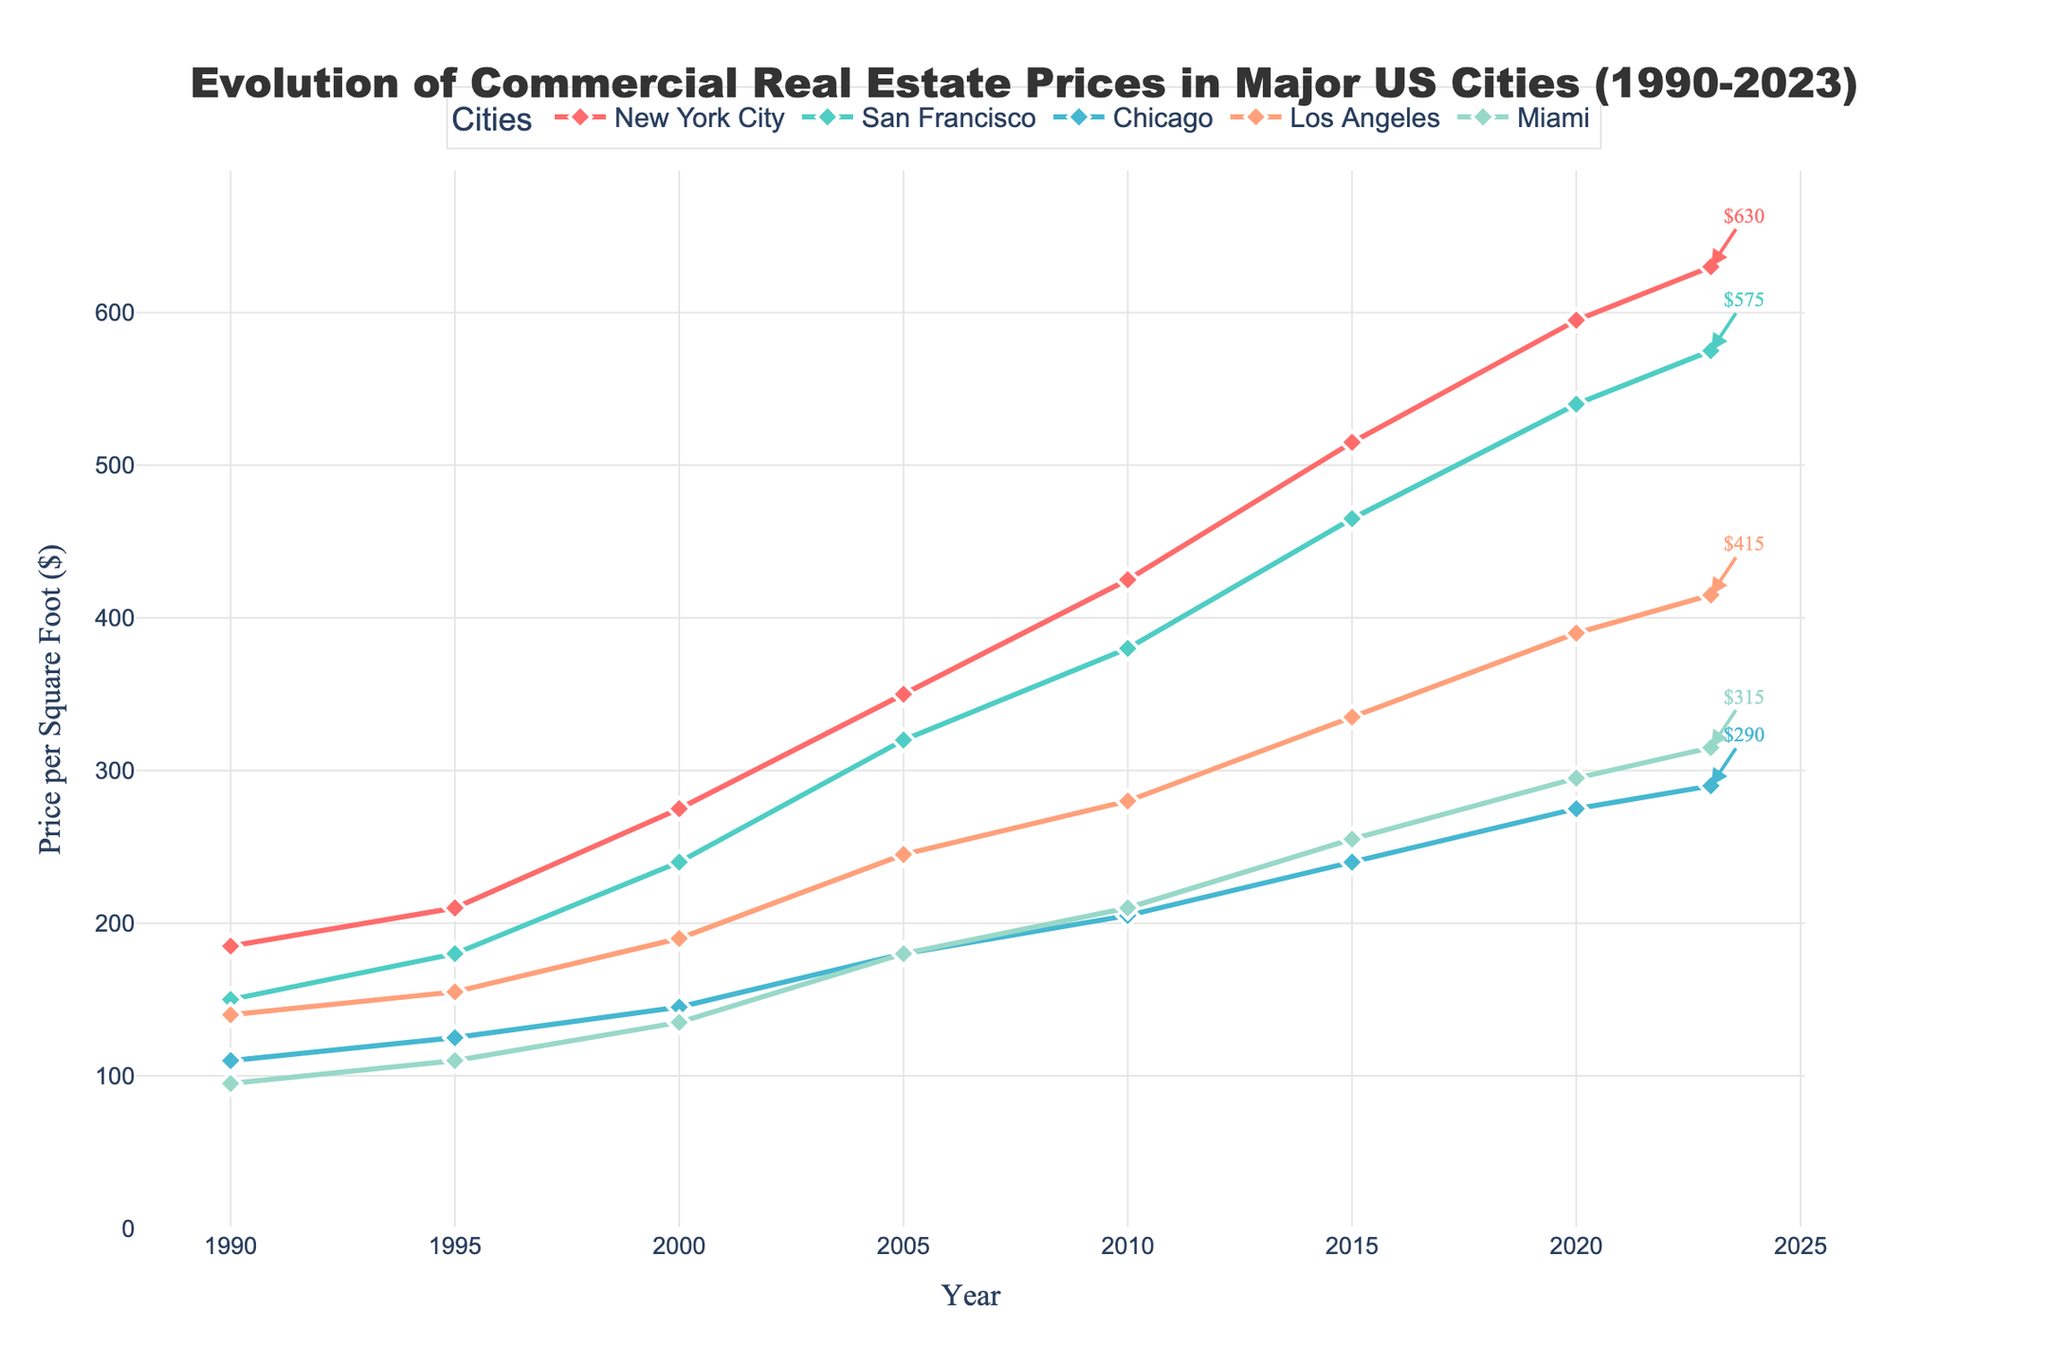What was the commercial real estate price per square foot in New York City in 1990? Identify the point on the plot corresponding to New York City and the year 1990. The value at this point is 185.
Answer: 185 Which city had the highest average commercial real estate price per square foot in 2023? Locate the year 2023 on the x-axis and compare the endpoints of the lines representing each city. The highest point is New York City with $630 per square foot.
Answer: New York City By how much did the commercial real estate price in Miami increase from 1990 to 2023? Find the values for Miami for the years 1990 and 2023, which are 95 and 315 respectively. Calculate the increase as 315 - 95.
Answer: 220 Which two cities had the closest commercial real estate prices per square foot in 2023? Compare the endpoints of the lines for the year 2023 for all cities and see which two are closest numerically. San Francisco ($575) and Los Angeles ($415) seem the closest among pairs; however, these two are not closely matched like others. Hence, a reevaluation indicates no obvious match in the provided data.
Answer: N/A During which time interval did Chicago see the most significant increase in commercial real estate prices? Identify the steepest slope in the line corresponding to Chicago by comparing changes between intervals: 1990-1995, 1995-2000, 2000-2005, 2005-2010, 2010-2015, 2015-2020, and 2020-2023. The largest increase is from 2000 to 2005 ($145 to $180).
Answer: 2000-2005 What's the average increase in commercial real estate prices per decade in San Francisco from 1990 to 2020? Calculate the price difference for each decade (1990-2000, 2000-2010, 2010-2020), sum them, and divide by 3. Differences: 240-150=90, 380-240=140, 540-380=160. Average increase: (90+140+160)/3 = 130.
Answer: 130 Which city had the most stable growth in commercial real estate prices from 1990 to 2023? Assess the smoothness and less variability in the slope of the lines for each city from 1990 to 2023. Chicago shows relatively stable growth compared to other cities.
Answer: Chicago What is the combined commercial real estate price per square foot for Los Angeles and Miami in 2020? Identify the prices for Los Angeles ($390) and Miami ($295) for the year 2020 and sum them: 390 + 295.
Answer: 685 How does the commercial real estate price growth rate in Los Angeles compare between the decades 1990-2000 and 2010-2020? Calculate the difference for each decade (200-150 and 390-280), and compare them. Growth rates: 2000-1990: 50, 2020-2010: 110. Los Angeles grew noticeably more in the later decade.
Answer: Higher in 2010-2020 By what percentage did the commercial real estate price in New York City increase from 2000 to 2023? Calculate the initial and final values (2000: $275, 2023: $630). Percentage increase = ((630-275)/275)*100. Approximately (355/275)*100 ≈ 129%.
Answer: 129% 